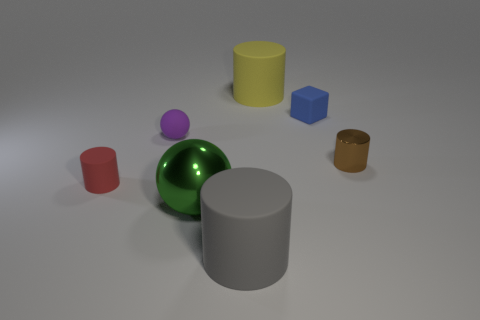Add 3 big yellow cylinders. How many objects exist? 10 Subtract all cylinders. How many objects are left? 3 Subtract 0 yellow balls. How many objects are left? 7 Subtract all large yellow objects. Subtract all red matte things. How many objects are left? 5 Add 3 yellow matte cylinders. How many yellow matte cylinders are left? 4 Add 5 big yellow metal blocks. How many big yellow metal blocks exist? 5 